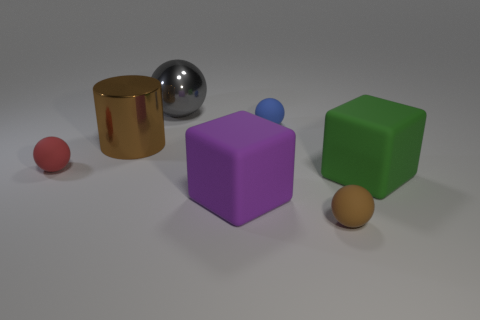Which objects in the image have reflective surfaces? The cylinder and the sphere to its right have reflective surfaces, demonstrated by the way they cast highlights and reflections. Are the reflective qualities of the two objects the same? No, the cylinder's surface seems to reflect light more intensely, suggesting it might be a polished metal, while the sphere has a softer reflection, possibly indicative of a smooth plastic or coated material. 